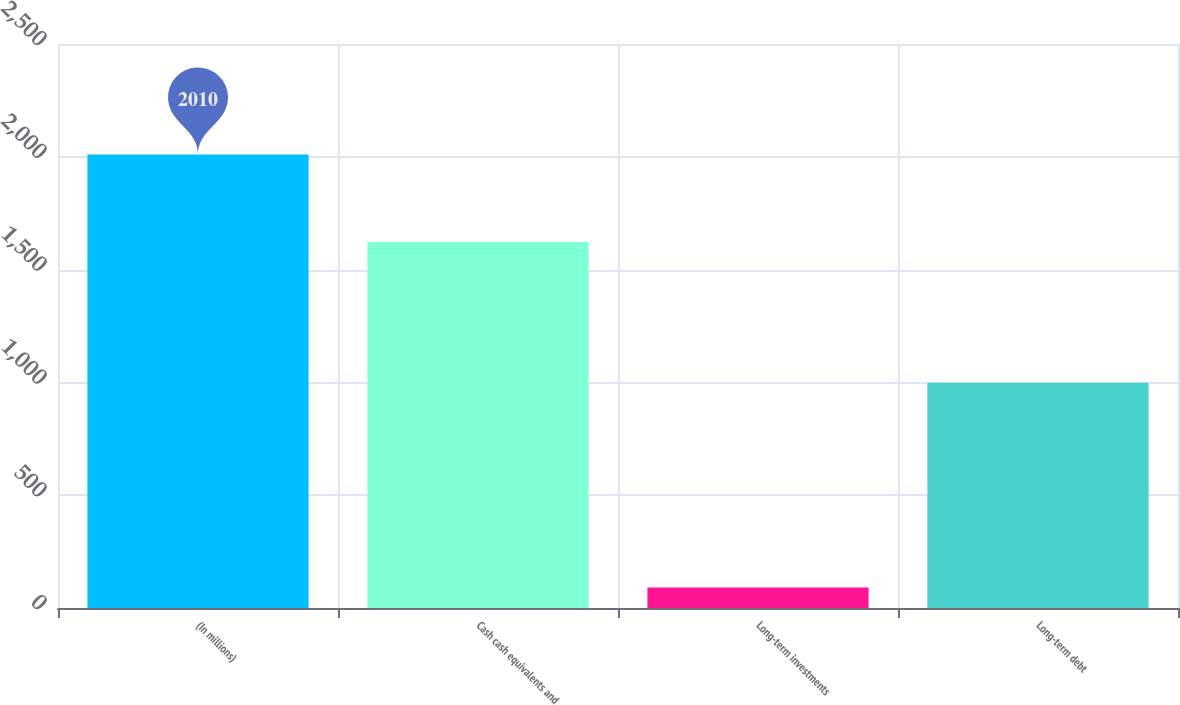Convert chart. <chart><loc_0><loc_0><loc_500><loc_500><bar_chart><fcel>(In millions)<fcel>Cash cash equivalents and<fcel>Long-term investments<fcel>Long-term debt<nl><fcel>2010<fcel>1622<fcel>91<fcel>998<nl></chart> 